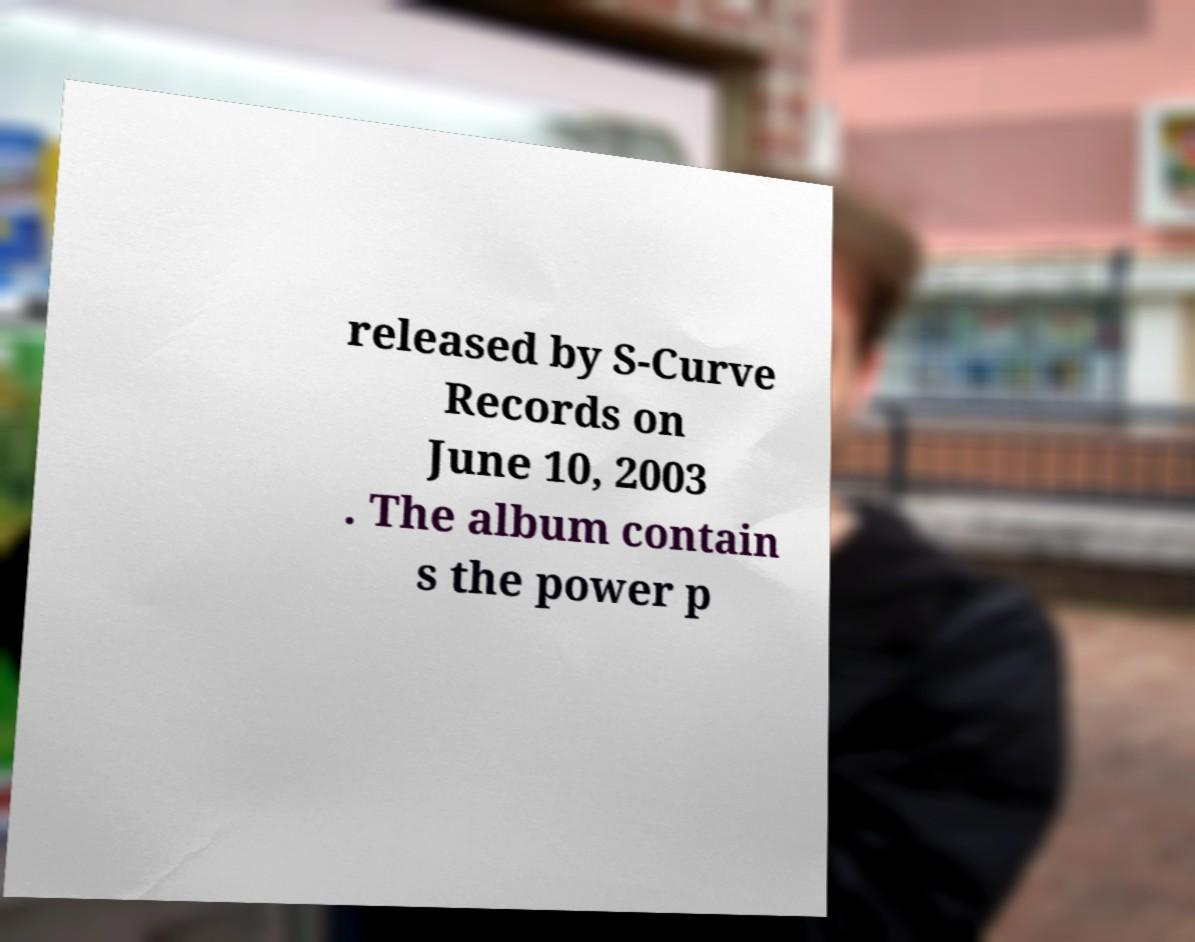Can you accurately transcribe the text from the provided image for me? Yes, the text on the paper in the image reads: 'released by S-Curve Records on June 10, 2003. The album contain s the power p'. However, the sentence seems to be cut off and unclear on what follows 'power p'. 